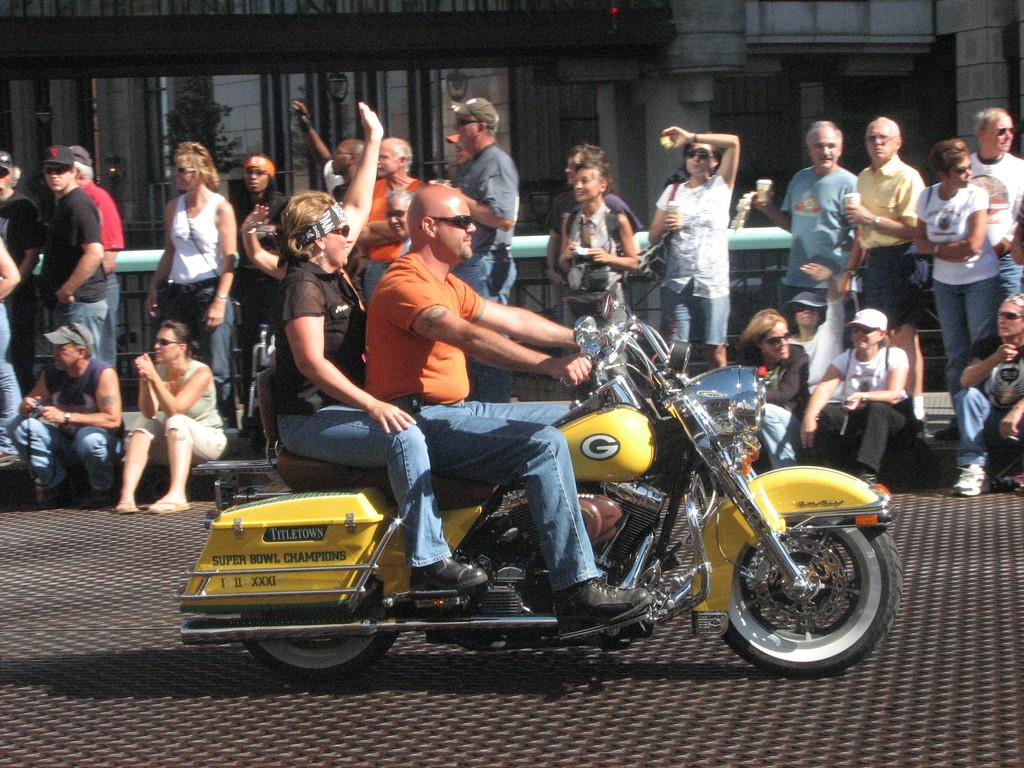What type of structures can be seen in the image? There are buildings in the image. What are the people in the image doing? The people in the image are standing and sitting. What vehicle is visible in the front of the image? There is a motorcycle in the front of the image. What type of sign can be seen on the motorcycle in the image? There is no sign visible on the motorcycle in the image. What is the mass of the buildings in the image? The mass of the buildings cannot be determined from the image alone. 